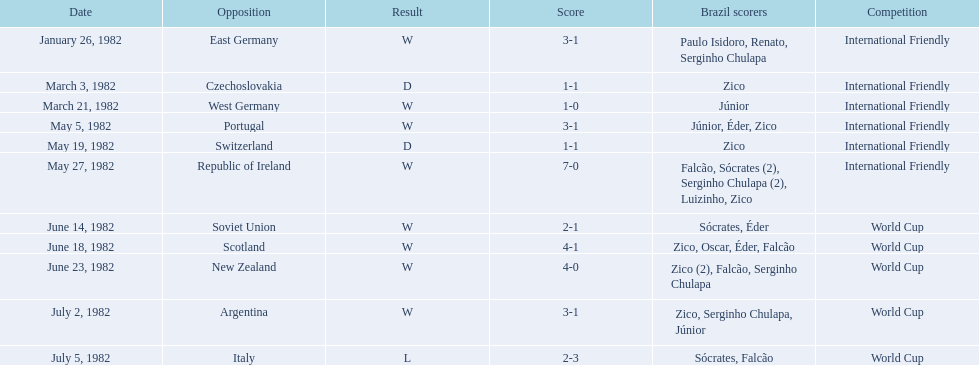What are all the dates of contests in 1982 in brazilian soccer? January 26, 1982, March 3, 1982, March 21, 1982, May 5, 1982, May 19, 1982, May 27, 1982, June 14, 1982, June 18, 1982, June 23, 1982, July 2, 1982, July 5, 1982. Which of these dates is at the pinnacle of the chart? January 26, 1982. 